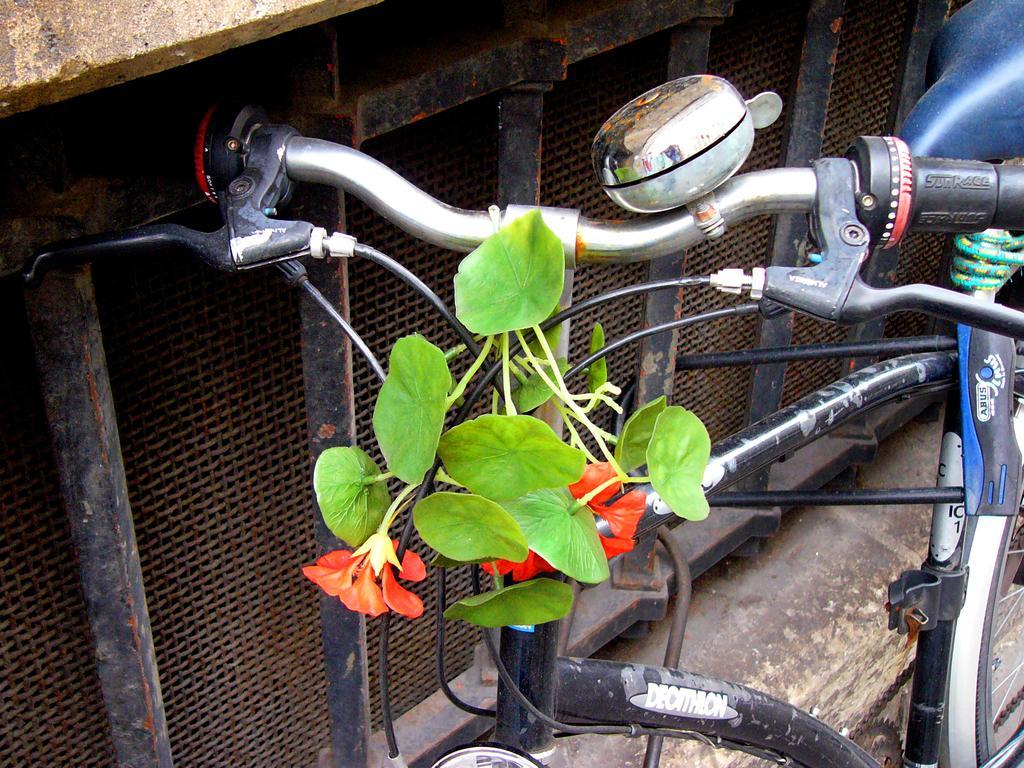How would you summarize this image in a sentence or two? In this picture I can see a bicycle. There are leaves and flowers on the cables of a bicycle, and in the background there is an object. 